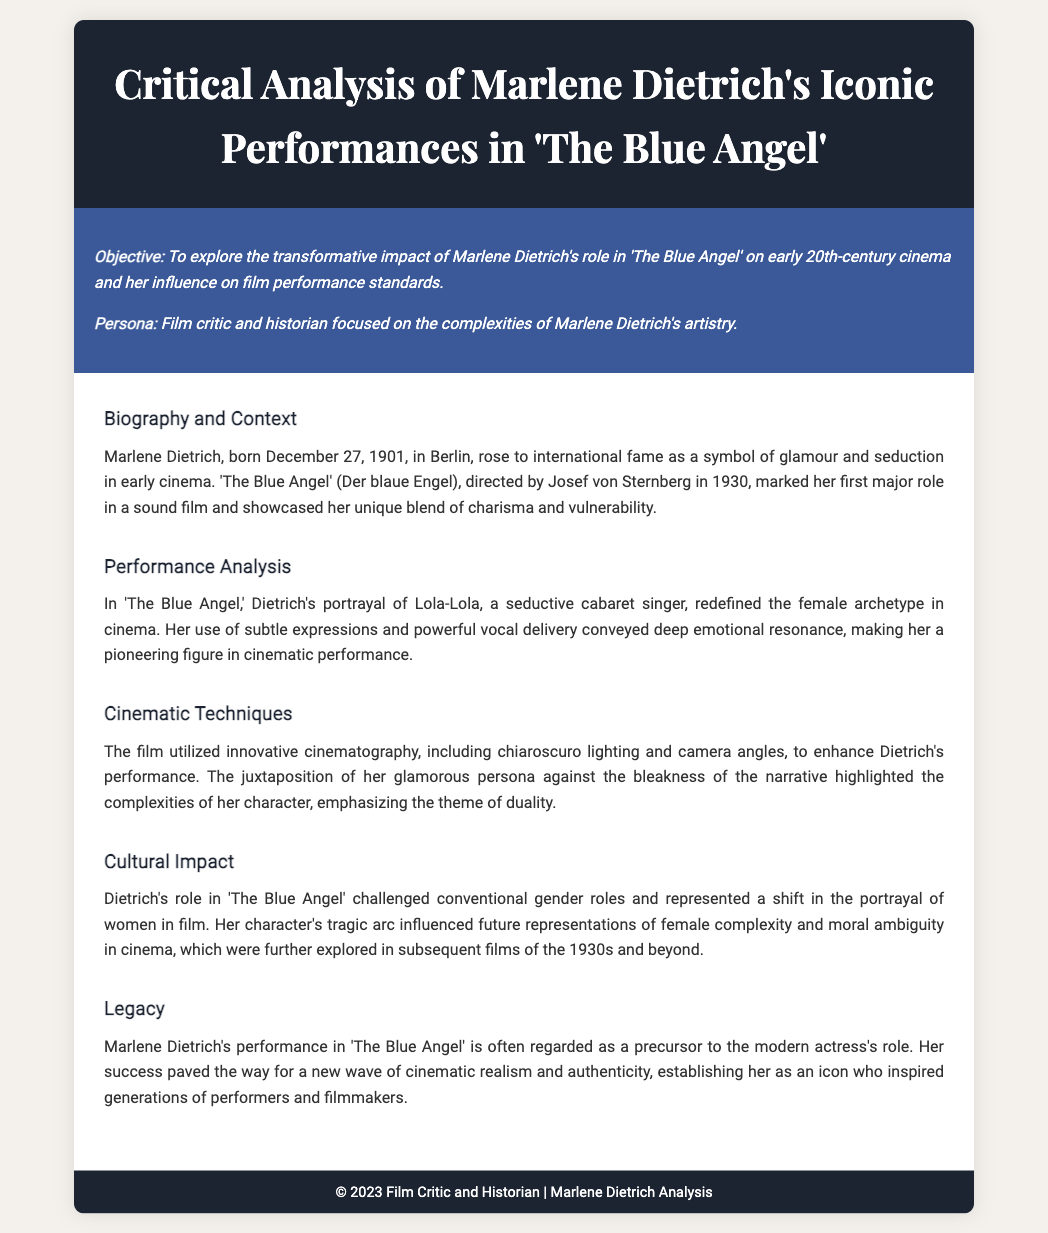What is the title of the film discussed? The title is mentioned in the header of the document and is "The Blue Angel."
Answer: The Blue Angel Who directed "The Blue Angel"? The director's name is provided in the biography section, which states Josef von Sternberg directed the film.
Answer: Josef von Sternberg In what year was "The Blue Angel" released? The release year is indicated in the document, specifically mentioned alongside its context as 1930.
Answer: 1930 What was the name of Marlene Dietrich's character in the film? The character's name is highlighted in the performance analysis section as Lola-Lola.
Answer: Lola-Lola What major theme is emphasized in Dietrich's character arc? The document discusses the theme of duality, particularly in the context of her character's portrayal.
Answer: Duality How did Dietrich redefine female archetypes in cinema? The document states that her performance conveyed deep emotional resonance, marking a change in portrayal standards.
Answer: Emotional resonance What impact did Dietrich's role have on future representations of women? The cultural impact section notes that her character influenced representations of female complexity and moral ambiguity.
Answer: Female complexity What was Marlene Dietrich’s birth date? The document provides her birth date in the biography section, which is December 27, 1901.
Answer: December 27, 1901 Which cinematic technique was employed to enhance Dietrich's performance? The document mentions the use of chiaroscuro lighting as a key cinematic technique.
Answer: Chiaroscuro lighting 